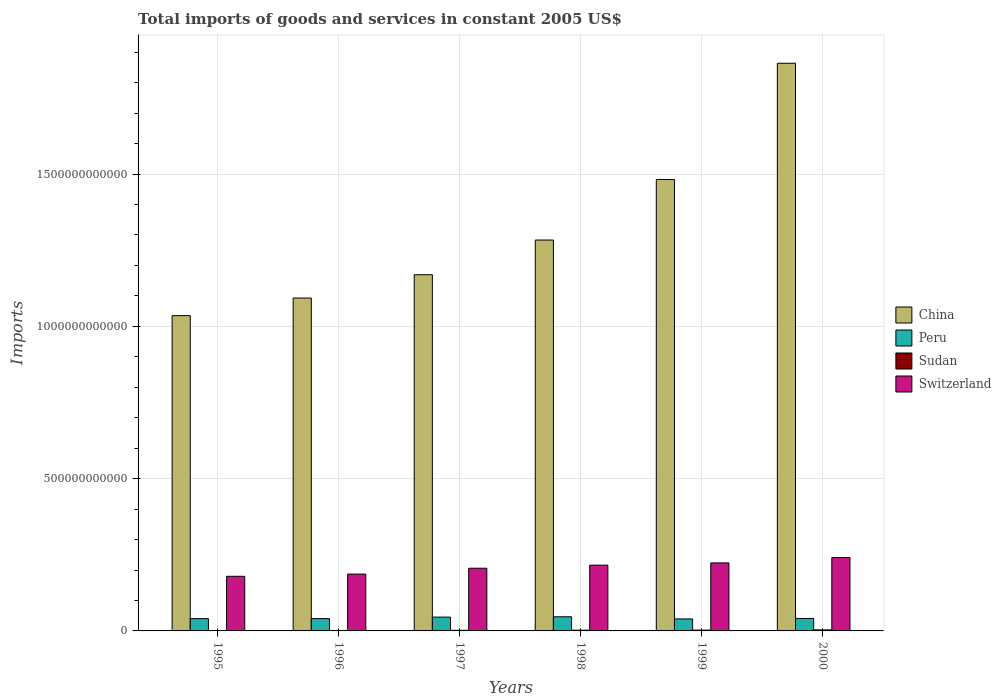How many different coloured bars are there?
Keep it short and to the point. 4. How many groups of bars are there?
Give a very brief answer. 6. Are the number of bars per tick equal to the number of legend labels?
Make the answer very short. Yes. What is the label of the 4th group of bars from the left?
Make the answer very short. 1998. What is the total imports of goods and services in China in 1997?
Keep it short and to the point. 1.17e+12. Across all years, what is the maximum total imports of goods and services in Peru?
Provide a succinct answer. 4.64e+1. Across all years, what is the minimum total imports of goods and services in Sudan?
Keep it short and to the point. 1.12e+09. In which year was the total imports of goods and services in Sudan maximum?
Make the answer very short. 2000. In which year was the total imports of goods and services in Sudan minimum?
Give a very brief answer. 1995. What is the total total imports of goods and services in Sudan in the graph?
Give a very brief answer. 1.32e+1. What is the difference between the total imports of goods and services in China in 1997 and that in 1998?
Provide a succinct answer. -1.14e+11. What is the difference between the total imports of goods and services in China in 2000 and the total imports of goods and services in Sudan in 1999?
Your answer should be compact. 1.86e+12. What is the average total imports of goods and services in China per year?
Give a very brief answer. 1.32e+12. In the year 1997, what is the difference between the total imports of goods and services in Sudan and total imports of goods and services in Switzerland?
Your answer should be compact. -2.04e+11. What is the ratio of the total imports of goods and services in Sudan in 1996 to that in 1998?
Your response must be concise. 0.65. What is the difference between the highest and the second highest total imports of goods and services in Switzerland?
Provide a short and direct response. 1.76e+1. What is the difference between the highest and the lowest total imports of goods and services in Switzerland?
Make the answer very short. 6.16e+1. What does the 4th bar from the left in 1995 represents?
Offer a terse response. Switzerland. How many bars are there?
Your answer should be very brief. 24. What is the difference between two consecutive major ticks on the Y-axis?
Your answer should be compact. 5.00e+11. Does the graph contain any zero values?
Keep it short and to the point. No. Does the graph contain grids?
Provide a short and direct response. Yes. How are the legend labels stacked?
Provide a succinct answer. Vertical. What is the title of the graph?
Keep it short and to the point. Total imports of goods and services in constant 2005 US$. Does "Ireland" appear as one of the legend labels in the graph?
Provide a succinct answer. No. What is the label or title of the Y-axis?
Provide a succinct answer. Imports. What is the Imports in China in 1995?
Give a very brief answer. 1.04e+12. What is the Imports in Peru in 1995?
Your response must be concise. 4.04e+1. What is the Imports in Sudan in 1995?
Your answer should be very brief. 1.12e+09. What is the Imports in Switzerland in 1995?
Ensure brevity in your answer.  1.79e+11. What is the Imports in China in 1996?
Provide a short and direct response. 1.09e+12. What is the Imports in Peru in 1996?
Your answer should be compact. 4.04e+1. What is the Imports in Sudan in 1996?
Give a very brief answer. 1.56e+09. What is the Imports of Switzerland in 1996?
Provide a succinct answer. 1.87e+11. What is the Imports in China in 1997?
Your answer should be compact. 1.17e+12. What is the Imports of Peru in 1997?
Provide a short and direct response. 4.54e+1. What is the Imports in Sudan in 1997?
Offer a very short reply. 2.02e+09. What is the Imports of Switzerland in 1997?
Provide a succinct answer. 2.06e+11. What is the Imports of China in 1998?
Offer a terse response. 1.28e+12. What is the Imports of Peru in 1998?
Give a very brief answer. 4.64e+1. What is the Imports of Sudan in 1998?
Offer a very short reply. 2.40e+09. What is the Imports in Switzerland in 1998?
Ensure brevity in your answer.  2.16e+11. What is the Imports of China in 1999?
Provide a succinct answer. 1.48e+12. What is the Imports of Peru in 1999?
Offer a terse response. 3.94e+1. What is the Imports in Sudan in 1999?
Offer a very short reply. 2.71e+09. What is the Imports in Switzerland in 1999?
Your answer should be very brief. 2.23e+11. What is the Imports of China in 2000?
Your response must be concise. 1.86e+12. What is the Imports of Peru in 2000?
Give a very brief answer. 4.09e+1. What is the Imports in Sudan in 2000?
Keep it short and to the point. 3.37e+09. What is the Imports of Switzerland in 2000?
Provide a short and direct response. 2.41e+11. Across all years, what is the maximum Imports of China?
Ensure brevity in your answer.  1.86e+12. Across all years, what is the maximum Imports of Peru?
Give a very brief answer. 4.64e+1. Across all years, what is the maximum Imports in Sudan?
Provide a succinct answer. 3.37e+09. Across all years, what is the maximum Imports in Switzerland?
Provide a short and direct response. 2.41e+11. Across all years, what is the minimum Imports in China?
Your answer should be compact. 1.04e+12. Across all years, what is the minimum Imports of Peru?
Keep it short and to the point. 3.94e+1. Across all years, what is the minimum Imports of Sudan?
Make the answer very short. 1.12e+09. Across all years, what is the minimum Imports of Switzerland?
Provide a short and direct response. 1.79e+11. What is the total Imports in China in the graph?
Offer a terse response. 7.93e+12. What is the total Imports of Peru in the graph?
Make the answer very short. 2.53e+11. What is the total Imports in Sudan in the graph?
Offer a terse response. 1.32e+1. What is the total Imports in Switzerland in the graph?
Make the answer very short. 1.25e+12. What is the difference between the Imports in China in 1995 and that in 1996?
Give a very brief answer. -5.78e+1. What is the difference between the Imports of Peru in 1995 and that in 1996?
Make the answer very short. -5.37e+07. What is the difference between the Imports in Sudan in 1995 and that in 1996?
Keep it short and to the point. -4.49e+08. What is the difference between the Imports of Switzerland in 1995 and that in 1996?
Offer a very short reply. -7.30e+09. What is the difference between the Imports of China in 1995 and that in 1997?
Your response must be concise. -1.34e+11. What is the difference between the Imports of Peru in 1995 and that in 1997?
Ensure brevity in your answer.  -4.97e+09. What is the difference between the Imports of Sudan in 1995 and that in 1997?
Offer a terse response. -9.07e+08. What is the difference between the Imports in Switzerland in 1995 and that in 1997?
Make the answer very short. -2.65e+1. What is the difference between the Imports in China in 1995 and that in 1998?
Keep it short and to the point. -2.48e+11. What is the difference between the Imports in Peru in 1995 and that in 1998?
Give a very brief answer. -6.03e+09. What is the difference between the Imports in Sudan in 1995 and that in 1998?
Provide a short and direct response. -1.28e+09. What is the difference between the Imports in Switzerland in 1995 and that in 1998?
Give a very brief answer. -3.66e+1. What is the difference between the Imports of China in 1995 and that in 1999?
Your answer should be compact. -4.47e+11. What is the difference between the Imports in Peru in 1995 and that in 1999?
Provide a short and direct response. 1.01e+09. What is the difference between the Imports of Sudan in 1995 and that in 1999?
Offer a terse response. -1.60e+09. What is the difference between the Imports in Switzerland in 1995 and that in 1999?
Give a very brief answer. -4.40e+1. What is the difference between the Imports in China in 1995 and that in 2000?
Ensure brevity in your answer.  -8.29e+11. What is the difference between the Imports in Peru in 1995 and that in 2000?
Make the answer very short. -4.97e+08. What is the difference between the Imports in Sudan in 1995 and that in 2000?
Give a very brief answer. -2.25e+09. What is the difference between the Imports of Switzerland in 1995 and that in 2000?
Provide a short and direct response. -6.16e+1. What is the difference between the Imports of China in 1996 and that in 1997?
Give a very brief answer. -7.66e+1. What is the difference between the Imports in Peru in 1996 and that in 1997?
Offer a terse response. -4.92e+09. What is the difference between the Imports of Sudan in 1996 and that in 1997?
Provide a short and direct response. -4.59e+08. What is the difference between the Imports of Switzerland in 1996 and that in 1997?
Provide a short and direct response. -1.92e+1. What is the difference between the Imports of China in 1996 and that in 1998?
Give a very brief answer. -1.90e+11. What is the difference between the Imports in Peru in 1996 and that in 1998?
Give a very brief answer. -5.97e+09. What is the difference between the Imports in Sudan in 1996 and that in 1998?
Your answer should be compact. -8.34e+08. What is the difference between the Imports of Switzerland in 1996 and that in 1998?
Offer a terse response. -2.93e+1. What is the difference between the Imports in China in 1996 and that in 1999?
Provide a short and direct response. -3.89e+11. What is the difference between the Imports of Peru in 1996 and that in 1999?
Offer a very short reply. 1.07e+09. What is the difference between the Imports of Sudan in 1996 and that in 1999?
Ensure brevity in your answer.  -1.15e+09. What is the difference between the Imports in Switzerland in 1996 and that in 1999?
Your response must be concise. -3.67e+1. What is the difference between the Imports of China in 1996 and that in 2000?
Keep it short and to the point. -7.71e+11. What is the difference between the Imports in Peru in 1996 and that in 2000?
Keep it short and to the point. -4.43e+08. What is the difference between the Imports of Sudan in 1996 and that in 2000?
Give a very brief answer. -1.81e+09. What is the difference between the Imports in Switzerland in 1996 and that in 2000?
Offer a very short reply. -5.43e+1. What is the difference between the Imports in China in 1997 and that in 1998?
Give a very brief answer. -1.14e+11. What is the difference between the Imports of Peru in 1997 and that in 1998?
Offer a terse response. -1.05e+09. What is the difference between the Imports in Sudan in 1997 and that in 1998?
Your answer should be compact. -3.75e+08. What is the difference between the Imports of Switzerland in 1997 and that in 1998?
Keep it short and to the point. -1.01e+1. What is the difference between the Imports in China in 1997 and that in 1999?
Ensure brevity in your answer.  -3.13e+11. What is the difference between the Imports in Peru in 1997 and that in 1999?
Keep it short and to the point. 5.99e+09. What is the difference between the Imports of Sudan in 1997 and that in 1999?
Ensure brevity in your answer.  -6.88e+08. What is the difference between the Imports of Switzerland in 1997 and that in 1999?
Ensure brevity in your answer.  -1.75e+1. What is the difference between the Imports of China in 1997 and that in 2000?
Give a very brief answer. -6.94e+11. What is the difference between the Imports of Peru in 1997 and that in 2000?
Your answer should be compact. 4.48e+09. What is the difference between the Imports of Sudan in 1997 and that in 2000?
Your answer should be very brief. -1.35e+09. What is the difference between the Imports in Switzerland in 1997 and that in 2000?
Your response must be concise. -3.51e+1. What is the difference between the Imports in China in 1998 and that in 1999?
Ensure brevity in your answer.  -1.99e+11. What is the difference between the Imports of Peru in 1998 and that in 1999?
Your answer should be very brief. 7.04e+09. What is the difference between the Imports of Sudan in 1998 and that in 1999?
Your answer should be compact. -3.13e+08. What is the difference between the Imports in Switzerland in 1998 and that in 1999?
Your answer should be very brief. -7.42e+09. What is the difference between the Imports in China in 1998 and that in 2000?
Keep it short and to the point. -5.80e+11. What is the difference between the Imports in Peru in 1998 and that in 2000?
Keep it short and to the point. 5.53e+09. What is the difference between the Imports of Sudan in 1998 and that in 2000?
Your response must be concise. -9.72e+08. What is the difference between the Imports of Switzerland in 1998 and that in 2000?
Your answer should be compact. -2.50e+1. What is the difference between the Imports in China in 1999 and that in 2000?
Give a very brief answer. -3.82e+11. What is the difference between the Imports in Peru in 1999 and that in 2000?
Offer a terse response. -1.51e+09. What is the difference between the Imports of Sudan in 1999 and that in 2000?
Your response must be concise. -6.59e+08. What is the difference between the Imports in Switzerland in 1999 and that in 2000?
Provide a succinct answer. -1.76e+1. What is the difference between the Imports of China in 1995 and the Imports of Peru in 1996?
Offer a very short reply. 9.95e+11. What is the difference between the Imports of China in 1995 and the Imports of Sudan in 1996?
Your answer should be compact. 1.03e+12. What is the difference between the Imports in China in 1995 and the Imports in Switzerland in 1996?
Give a very brief answer. 8.49e+11. What is the difference between the Imports in Peru in 1995 and the Imports in Sudan in 1996?
Your answer should be very brief. 3.88e+1. What is the difference between the Imports of Peru in 1995 and the Imports of Switzerland in 1996?
Your response must be concise. -1.46e+11. What is the difference between the Imports of Sudan in 1995 and the Imports of Switzerland in 1996?
Your answer should be compact. -1.86e+11. What is the difference between the Imports of China in 1995 and the Imports of Peru in 1997?
Provide a succinct answer. 9.90e+11. What is the difference between the Imports of China in 1995 and the Imports of Sudan in 1997?
Provide a short and direct response. 1.03e+12. What is the difference between the Imports of China in 1995 and the Imports of Switzerland in 1997?
Make the answer very short. 8.29e+11. What is the difference between the Imports of Peru in 1995 and the Imports of Sudan in 1997?
Ensure brevity in your answer.  3.84e+1. What is the difference between the Imports of Peru in 1995 and the Imports of Switzerland in 1997?
Your answer should be compact. -1.65e+11. What is the difference between the Imports of Sudan in 1995 and the Imports of Switzerland in 1997?
Keep it short and to the point. -2.05e+11. What is the difference between the Imports in China in 1995 and the Imports in Peru in 1998?
Your response must be concise. 9.89e+11. What is the difference between the Imports of China in 1995 and the Imports of Sudan in 1998?
Your answer should be very brief. 1.03e+12. What is the difference between the Imports in China in 1995 and the Imports in Switzerland in 1998?
Ensure brevity in your answer.  8.19e+11. What is the difference between the Imports in Peru in 1995 and the Imports in Sudan in 1998?
Give a very brief answer. 3.80e+1. What is the difference between the Imports of Peru in 1995 and the Imports of Switzerland in 1998?
Your answer should be very brief. -1.76e+11. What is the difference between the Imports in Sudan in 1995 and the Imports in Switzerland in 1998?
Provide a succinct answer. -2.15e+11. What is the difference between the Imports of China in 1995 and the Imports of Peru in 1999?
Offer a terse response. 9.96e+11. What is the difference between the Imports in China in 1995 and the Imports in Sudan in 1999?
Offer a terse response. 1.03e+12. What is the difference between the Imports of China in 1995 and the Imports of Switzerland in 1999?
Offer a terse response. 8.12e+11. What is the difference between the Imports of Peru in 1995 and the Imports of Sudan in 1999?
Provide a short and direct response. 3.77e+1. What is the difference between the Imports in Peru in 1995 and the Imports in Switzerland in 1999?
Provide a succinct answer. -1.83e+11. What is the difference between the Imports of Sudan in 1995 and the Imports of Switzerland in 1999?
Ensure brevity in your answer.  -2.22e+11. What is the difference between the Imports of China in 1995 and the Imports of Peru in 2000?
Make the answer very short. 9.94e+11. What is the difference between the Imports in China in 1995 and the Imports in Sudan in 2000?
Make the answer very short. 1.03e+12. What is the difference between the Imports in China in 1995 and the Imports in Switzerland in 2000?
Ensure brevity in your answer.  7.94e+11. What is the difference between the Imports of Peru in 1995 and the Imports of Sudan in 2000?
Give a very brief answer. 3.70e+1. What is the difference between the Imports of Peru in 1995 and the Imports of Switzerland in 2000?
Provide a succinct answer. -2.01e+11. What is the difference between the Imports in Sudan in 1995 and the Imports in Switzerland in 2000?
Provide a succinct answer. -2.40e+11. What is the difference between the Imports of China in 1996 and the Imports of Peru in 1997?
Keep it short and to the point. 1.05e+12. What is the difference between the Imports of China in 1996 and the Imports of Sudan in 1997?
Your response must be concise. 1.09e+12. What is the difference between the Imports in China in 1996 and the Imports in Switzerland in 1997?
Ensure brevity in your answer.  8.87e+11. What is the difference between the Imports in Peru in 1996 and the Imports in Sudan in 1997?
Your answer should be very brief. 3.84e+1. What is the difference between the Imports in Peru in 1996 and the Imports in Switzerland in 1997?
Provide a succinct answer. -1.65e+11. What is the difference between the Imports of Sudan in 1996 and the Imports of Switzerland in 1997?
Ensure brevity in your answer.  -2.04e+11. What is the difference between the Imports in China in 1996 and the Imports in Peru in 1998?
Your answer should be very brief. 1.05e+12. What is the difference between the Imports of China in 1996 and the Imports of Sudan in 1998?
Offer a terse response. 1.09e+12. What is the difference between the Imports in China in 1996 and the Imports in Switzerland in 1998?
Keep it short and to the point. 8.77e+11. What is the difference between the Imports in Peru in 1996 and the Imports in Sudan in 1998?
Offer a terse response. 3.81e+1. What is the difference between the Imports of Peru in 1996 and the Imports of Switzerland in 1998?
Your answer should be compact. -1.75e+11. What is the difference between the Imports in Sudan in 1996 and the Imports in Switzerland in 1998?
Ensure brevity in your answer.  -2.14e+11. What is the difference between the Imports in China in 1996 and the Imports in Peru in 1999?
Make the answer very short. 1.05e+12. What is the difference between the Imports of China in 1996 and the Imports of Sudan in 1999?
Offer a very short reply. 1.09e+12. What is the difference between the Imports of China in 1996 and the Imports of Switzerland in 1999?
Provide a succinct answer. 8.70e+11. What is the difference between the Imports in Peru in 1996 and the Imports in Sudan in 1999?
Provide a short and direct response. 3.77e+1. What is the difference between the Imports of Peru in 1996 and the Imports of Switzerland in 1999?
Ensure brevity in your answer.  -1.83e+11. What is the difference between the Imports in Sudan in 1996 and the Imports in Switzerland in 1999?
Your answer should be very brief. -2.22e+11. What is the difference between the Imports in China in 1996 and the Imports in Peru in 2000?
Provide a succinct answer. 1.05e+12. What is the difference between the Imports of China in 1996 and the Imports of Sudan in 2000?
Your answer should be compact. 1.09e+12. What is the difference between the Imports of China in 1996 and the Imports of Switzerland in 2000?
Give a very brief answer. 8.52e+11. What is the difference between the Imports in Peru in 1996 and the Imports in Sudan in 2000?
Give a very brief answer. 3.71e+1. What is the difference between the Imports in Peru in 1996 and the Imports in Switzerland in 2000?
Offer a terse response. -2.00e+11. What is the difference between the Imports in Sudan in 1996 and the Imports in Switzerland in 2000?
Provide a succinct answer. -2.39e+11. What is the difference between the Imports of China in 1997 and the Imports of Peru in 1998?
Give a very brief answer. 1.12e+12. What is the difference between the Imports of China in 1997 and the Imports of Sudan in 1998?
Provide a short and direct response. 1.17e+12. What is the difference between the Imports in China in 1997 and the Imports in Switzerland in 1998?
Ensure brevity in your answer.  9.54e+11. What is the difference between the Imports in Peru in 1997 and the Imports in Sudan in 1998?
Offer a terse response. 4.30e+1. What is the difference between the Imports of Peru in 1997 and the Imports of Switzerland in 1998?
Offer a terse response. -1.71e+11. What is the difference between the Imports in Sudan in 1997 and the Imports in Switzerland in 1998?
Your answer should be very brief. -2.14e+11. What is the difference between the Imports in China in 1997 and the Imports in Peru in 1999?
Keep it short and to the point. 1.13e+12. What is the difference between the Imports of China in 1997 and the Imports of Sudan in 1999?
Keep it short and to the point. 1.17e+12. What is the difference between the Imports of China in 1997 and the Imports of Switzerland in 1999?
Ensure brevity in your answer.  9.46e+11. What is the difference between the Imports in Peru in 1997 and the Imports in Sudan in 1999?
Offer a terse response. 4.27e+1. What is the difference between the Imports of Peru in 1997 and the Imports of Switzerland in 1999?
Your answer should be compact. -1.78e+11. What is the difference between the Imports of Sudan in 1997 and the Imports of Switzerland in 1999?
Provide a short and direct response. -2.21e+11. What is the difference between the Imports of China in 1997 and the Imports of Peru in 2000?
Offer a very short reply. 1.13e+12. What is the difference between the Imports of China in 1997 and the Imports of Sudan in 2000?
Ensure brevity in your answer.  1.17e+12. What is the difference between the Imports of China in 1997 and the Imports of Switzerland in 2000?
Offer a very short reply. 9.29e+11. What is the difference between the Imports in Peru in 1997 and the Imports in Sudan in 2000?
Provide a succinct answer. 4.20e+1. What is the difference between the Imports in Peru in 1997 and the Imports in Switzerland in 2000?
Your answer should be very brief. -1.96e+11. What is the difference between the Imports in Sudan in 1997 and the Imports in Switzerland in 2000?
Offer a very short reply. -2.39e+11. What is the difference between the Imports of China in 1998 and the Imports of Peru in 1999?
Your response must be concise. 1.24e+12. What is the difference between the Imports of China in 1998 and the Imports of Sudan in 1999?
Keep it short and to the point. 1.28e+12. What is the difference between the Imports of China in 1998 and the Imports of Switzerland in 1999?
Your answer should be compact. 1.06e+12. What is the difference between the Imports of Peru in 1998 and the Imports of Sudan in 1999?
Make the answer very short. 4.37e+1. What is the difference between the Imports in Peru in 1998 and the Imports in Switzerland in 1999?
Make the answer very short. -1.77e+11. What is the difference between the Imports in Sudan in 1998 and the Imports in Switzerland in 1999?
Make the answer very short. -2.21e+11. What is the difference between the Imports in China in 1998 and the Imports in Peru in 2000?
Provide a short and direct response. 1.24e+12. What is the difference between the Imports of China in 1998 and the Imports of Sudan in 2000?
Keep it short and to the point. 1.28e+12. What is the difference between the Imports of China in 1998 and the Imports of Switzerland in 2000?
Make the answer very short. 1.04e+12. What is the difference between the Imports in Peru in 1998 and the Imports in Sudan in 2000?
Give a very brief answer. 4.31e+1. What is the difference between the Imports of Peru in 1998 and the Imports of Switzerland in 2000?
Keep it short and to the point. -1.95e+11. What is the difference between the Imports in Sudan in 1998 and the Imports in Switzerland in 2000?
Offer a very short reply. -2.39e+11. What is the difference between the Imports of China in 1999 and the Imports of Peru in 2000?
Give a very brief answer. 1.44e+12. What is the difference between the Imports of China in 1999 and the Imports of Sudan in 2000?
Offer a very short reply. 1.48e+12. What is the difference between the Imports of China in 1999 and the Imports of Switzerland in 2000?
Your answer should be very brief. 1.24e+12. What is the difference between the Imports of Peru in 1999 and the Imports of Sudan in 2000?
Your response must be concise. 3.60e+1. What is the difference between the Imports of Peru in 1999 and the Imports of Switzerland in 2000?
Offer a terse response. -2.02e+11. What is the difference between the Imports in Sudan in 1999 and the Imports in Switzerland in 2000?
Offer a terse response. -2.38e+11. What is the average Imports of China per year?
Offer a terse response. 1.32e+12. What is the average Imports in Peru per year?
Your answer should be very brief. 4.22e+1. What is the average Imports of Sudan per year?
Your response must be concise. 2.20e+09. What is the average Imports in Switzerland per year?
Your answer should be compact. 2.09e+11. In the year 1995, what is the difference between the Imports in China and Imports in Peru?
Provide a succinct answer. 9.95e+11. In the year 1995, what is the difference between the Imports of China and Imports of Sudan?
Your answer should be compact. 1.03e+12. In the year 1995, what is the difference between the Imports of China and Imports of Switzerland?
Offer a terse response. 8.56e+11. In the year 1995, what is the difference between the Imports of Peru and Imports of Sudan?
Provide a succinct answer. 3.93e+1. In the year 1995, what is the difference between the Imports of Peru and Imports of Switzerland?
Make the answer very short. -1.39e+11. In the year 1995, what is the difference between the Imports of Sudan and Imports of Switzerland?
Your answer should be compact. -1.78e+11. In the year 1996, what is the difference between the Imports in China and Imports in Peru?
Your answer should be compact. 1.05e+12. In the year 1996, what is the difference between the Imports in China and Imports in Sudan?
Your answer should be very brief. 1.09e+12. In the year 1996, what is the difference between the Imports in China and Imports in Switzerland?
Keep it short and to the point. 9.06e+11. In the year 1996, what is the difference between the Imports of Peru and Imports of Sudan?
Your response must be concise. 3.89e+1. In the year 1996, what is the difference between the Imports of Peru and Imports of Switzerland?
Ensure brevity in your answer.  -1.46e+11. In the year 1996, what is the difference between the Imports in Sudan and Imports in Switzerland?
Provide a succinct answer. -1.85e+11. In the year 1997, what is the difference between the Imports in China and Imports in Peru?
Your answer should be compact. 1.12e+12. In the year 1997, what is the difference between the Imports of China and Imports of Sudan?
Provide a succinct answer. 1.17e+12. In the year 1997, what is the difference between the Imports in China and Imports in Switzerland?
Provide a succinct answer. 9.64e+11. In the year 1997, what is the difference between the Imports in Peru and Imports in Sudan?
Make the answer very short. 4.33e+1. In the year 1997, what is the difference between the Imports of Peru and Imports of Switzerland?
Keep it short and to the point. -1.60e+11. In the year 1997, what is the difference between the Imports in Sudan and Imports in Switzerland?
Provide a short and direct response. -2.04e+11. In the year 1998, what is the difference between the Imports in China and Imports in Peru?
Give a very brief answer. 1.24e+12. In the year 1998, what is the difference between the Imports in China and Imports in Sudan?
Your answer should be compact. 1.28e+12. In the year 1998, what is the difference between the Imports of China and Imports of Switzerland?
Keep it short and to the point. 1.07e+12. In the year 1998, what is the difference between the Imports of Peru and Imports of Sudan?
Keep it short and to the point. 4.40e+1. In the year 1998, what is the difference between the Imports in Peru and Imports in Switzerland?
Give a very brief answer. -1.70e+11. In the year 1998, what is the difference between the Imports in Sudan and Imports in Switzerland?
Give a very brief answer. -2.14e+11. In the year 1999, what is the difference between the Imports of China and Imports of Peru?
Give a very brief answer. 1.44e+12. In the year 1999, what is the difference between the Imports in China and Imports in Sudan?
Give a very brief answer. 1.48e+12. In the year 1999, what is the difference between the Imports of China and Imports of Switzerland?
Give a very brief answer. 1.26e+12. In the year 1999, what is the difference between the Imports of Peru and Imports of Sudan?
Provide a succinct answer. 3.67e+1. In the year 1999, what is the difference between the Imports of Peru and Imports of Switzerland?
Your response must be concise. -1.84e+11. In the year 1999, what is the difference between the Imports of Sudan and Imports of Switzerland?
Your answer should be compact. -2.21e+11. In the year 2000, what is the difference between the Imports of China and Imports of Peru?
Give a very brief answer. 1.82e+12. In the year 2000, what is the difference between the Imports of China and Imports of Sudan?
Give a very brief answer. 1.86e+12. In the year 2000, what is the difference between the Imports of China and Imports of Switzerland?
Offer a very short reply. 1.62e+12. In the year 2000, what is the difference between the Imports in Peru and Imports in Sudan?
Provide a short and direct response. 3.75e+1. In the year 2000, what is the difference between the Imports of Peru and Imports of Switzerland?
Your answer should be compact. -2.00e+11. In the year 2000, what is the difference between the Imports of Sudan and Imports of Switzerland?
Your response must be concise. -2.38e+11. What is the ratio of the Imports in China in 1995 to that in 1996?
Keep it short and to the point. 0.95. What is the ratio of the Imports of Peru in 1995 to that in 1996?
Give a very brief answer. 1. What is the ratio of the Imports in Sudan in 1995 to that in 1996?
Offer a very short reply. 0.71. What is the ratio of the Imports of Switzerland in 1995 to that in 1996?
Provide a short and direct response. 0.96. What is the ratio of the Imports of China in 1995 to that in 1997?
Keep it short and to the point. 0.89. What is the ratio of the Imports in Peru in 1995 to that in 1997?
Your answer should be compact. 0.89. What is the ratio of the Imports in Sudan in 1995 to that in 1997?
Keep it short and to the point. 0.55. What is the ratio of the Imports in Switzerland in 1995 to that in 1997?
Make the answer very short. 0.87. What is the ratio of the Imports in China in 1995 to that in 1998?
Offer a terse response. 0.81. What is the ratio of the Imports of Peru in 1995 to that in 1998?
Offer a very short reply. 0.87. What is the ratio of the Imports in Sudan in 1995 to that in 1998?
Make the answer very short. 0.47. What is the ratio of the Imports of Switzerland in 1995 to that in 1998?
Your answer should be compact. 0.83. What is the ratio of the Imports of China in 1995 to that in 1999?
Provide a short and direct response. 0.7. What is the ratio of the Imports in Peru in 1995 to that in 1999?
Make the answer very short. 1.03. What is the ratio of the Imports in Sudan in 1995 to that in 1999?
Your answer should be very brief. 0.41. What is the ratio of the Imports in Switzerland in 1995 to that in 1999?
Keep it short and to the point. 0.8. What is the ratio of the Imports of China in 1995 to that in 2000?
Your answer should be compact. 0.56. What is the ratio of the Imports of Sudan in 1995 to that in 2000?
Offer a very short reply. 0.33. What is the ratio of the Imports in Switzerland in 1995 to that in 2000?
Your answer should be compact. 0.74. What is the ratio of the Imports of China in 1996 to that in 1997?
Give a very brief answer. 0.93. What is the ratio of the Imports in Peru in 1996 to that in 1997?
Keep it short and to the point. 0.89. What is the ratio of the Imports in Sudan in 1996 to that in 1997?
Your answer should be very brief. 0.77. What is the ratio of the Imports of Switzerland in 1996 to that in 1997?
Offer a very short reply. 0.91. What is the ratio of the Imports in China in 1996 to that in 1998?
Offer a very short reply. 0.85. What is the ratio of the Imports of Peru in 1996 to that in 1998?
Keep it short and to the point. 0.87. What is the ratio of the Imports in Sudan in 1996 to that in 1998?
Your response must be concise. 0.65. What is the ratio of the Imports of Switzerland in 1996 to that in 1998?
Your answer should be very brief. 0.86. What is the ratio of the Imports in China in 1996 to that in 1999?
Offer a very short reply. 0.74. What is the ratio of the Imports in Peru in 1996 to that in 1999?
Provide a succinct answer. 1.03. What is the ratio of the Imports of Sudan in 1996 to that in 1999?
Offer a terse response. 0.58. What is the ratio of the Imports of Switzerland in 1996 to that in 1999?
Give a very brief answer. 0.84. What is the ratio of the Imports in China in 1996 to that in 2000?
Your answer should be very brief. 0.59. What is the ratio of the Imports of Peru in 1996 to that in 2000?
Your answer should be compact. 0.99. What is the ratio of the Imports in Sudan in 1996 to that in 2000?
Provide a succinct answer. 0.46. What is the ratio of the Imports of Switzerland in 1996 to that in 2000?
Your response must be concise. 0.77. What is the ratio of the Imports in China in 1997 to that in 1998?
Offer a very short reply. 0.91. What is the ratio of the Imports in Peru in 1997 to that in 1998?
Provide a succinct answer. 0.98. What is the ratio of the Imports in Sudan in 1997 to that in 1998?
Offer a terse response. 0.84. What is the ratio of the Imports in Switzerland in 1997 to that in 1998?
Provide a short and direct response. 0.95. What is the ratio of the Imports in China in 1997 to that in 1999?
Offer a very short reply. 0.79. What is the ratio of the Imports of Peru in 1997 to that in 1999?
Provide a succinct answer. 1.15. What is the ratio of the Imports of Sudan in 1997 to that in 1999?
Offer a terse response. 0.75. What is the ratio of the Imports of Switzerland in 1997 to that in 1999?
Ensure brevity in your answer.  0.92. What is the ratio of the Imports of China in 1997 to that in 2000?
Your response must be concise. 0.63. What is the ratio of the Imports of Peru in 1997 to that in 2000?
Provide a succinct answer. 1.11. What is the ratio of the Imports of Sudan in 1997 to that in 2000?
Give a very brief answer. 0.6. What is the ratio of the Imports in Switzerland in 1997 to that in 2000?
Ensure brevity in your answer.  0.85. What is the ratio of the Imports of China in 1998 to that in 1999?
Your answer should be very brief. 0.87. What is the ratio of the Imports of Peru in 1998 to that in 1999?
Offer a very short reply. 1.18. What is the ratio of the Imports of Sudan in 1998 to that in 1999?
Offer a very short reply. 0.88. What is the ratio of the Imports in Switzerland in 1998 to that in 1999?
Provide a succinct answer. 0.97. What is the ratio of the Imports of China in 1998 to that in 2000?
Ensure brevity in your answer.  0.69. What is the ratio of the Imports of Peru in 1998 to that in 2000?
Make the answer very short. 1.14. What is the ratio of the Imports in Sudan in 1998 to that in 2000?
Provide a succinct answer. 0.71. What is the ratio of the Imports of Switzerland in 1998 to that in 2000?
Provide a succinct answer. 0.9. What is the ratio of the Imports in China in 1999 to that in 2000?
Ensure brevity in your answer.  0.8. What is the ratio of the Imports in Peru in 1999 to that in 2000?
Ensure brevity in your answer.  0.96. What is the ratio of the Imports of Sudan in 1999 to that in 2000?
Your response must be concise. 0.8. What is the ratio of the Imports in Switzerland in 1999 to that in 2000?
Offer a very short reply. 0.93. What is the difference between the highest and the second highest Imports of China?
Keep it short and to the point. 3.82e+11. What is the difference between the highest and the second highest Imports of Peru?
Provide a short and direct response. 1.05e+09. What is the difference between the highest and the second highest Imports in Sudan?
Keep it short and to the point. 6.59e+08. What is the difference between the highest and the second highest Imports of Switzerland?
Offer a terse response. 1.76e+1. What is the difference between the highest and the lowest Imports in China?
Your answer should be very brief. 8.29e+11. What is the difference between the highest and the lowest Imports of Peru?
Offer a terse response. 7.04e+09. What is the difference between the highest and the lowest Imports in Sudan?
Offer a terse response. 2.25e+09. What is the difference between the highest and the lowest Imports in Switzerland?
Offer a terse response. 6.16e+1. 